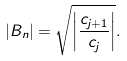Convert formula to latex. <formula><loc_0><loc_0><loc_500><loc_500>| B _ { n } | = \sqrt { \left | \frac { c _ { j + 1 } } { c _ { j } } \right | } .</formula> 